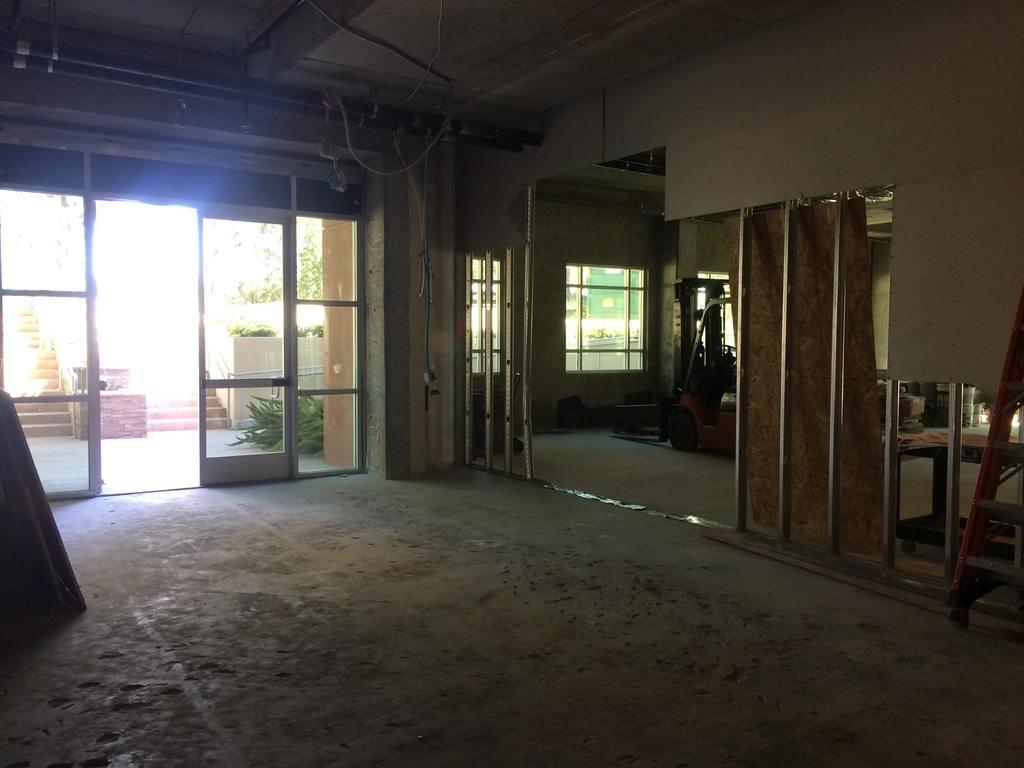Please provide a concise description of this image. This is the inside picture of the room. In this image there are glass doors. On the right side of the image there are a few objects. There is a machine. There is a glass window. At the bottom of the image there is a floor. On the left side of the image there is some wooden object. There are plants, trees. There are stairs. 